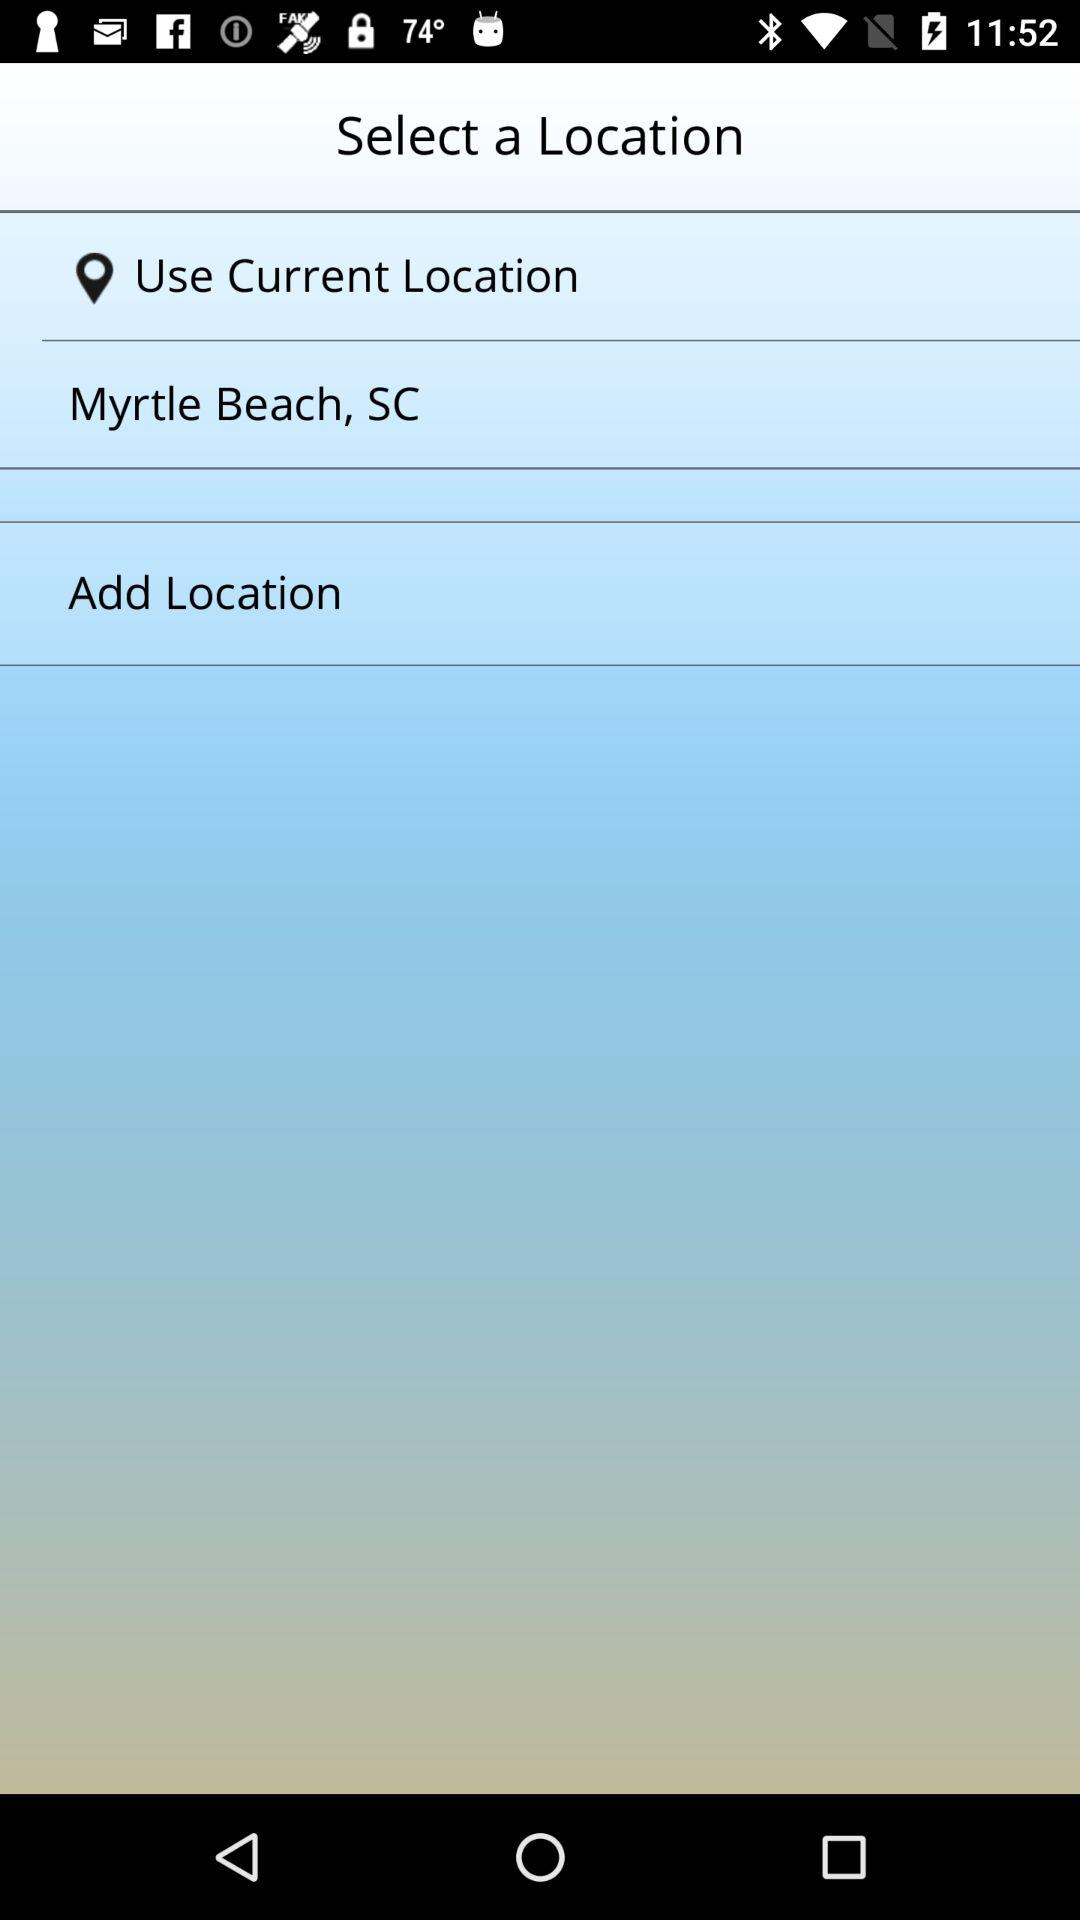What is the mentioned location? The mentioned location is Myrtle Beach, SC. 